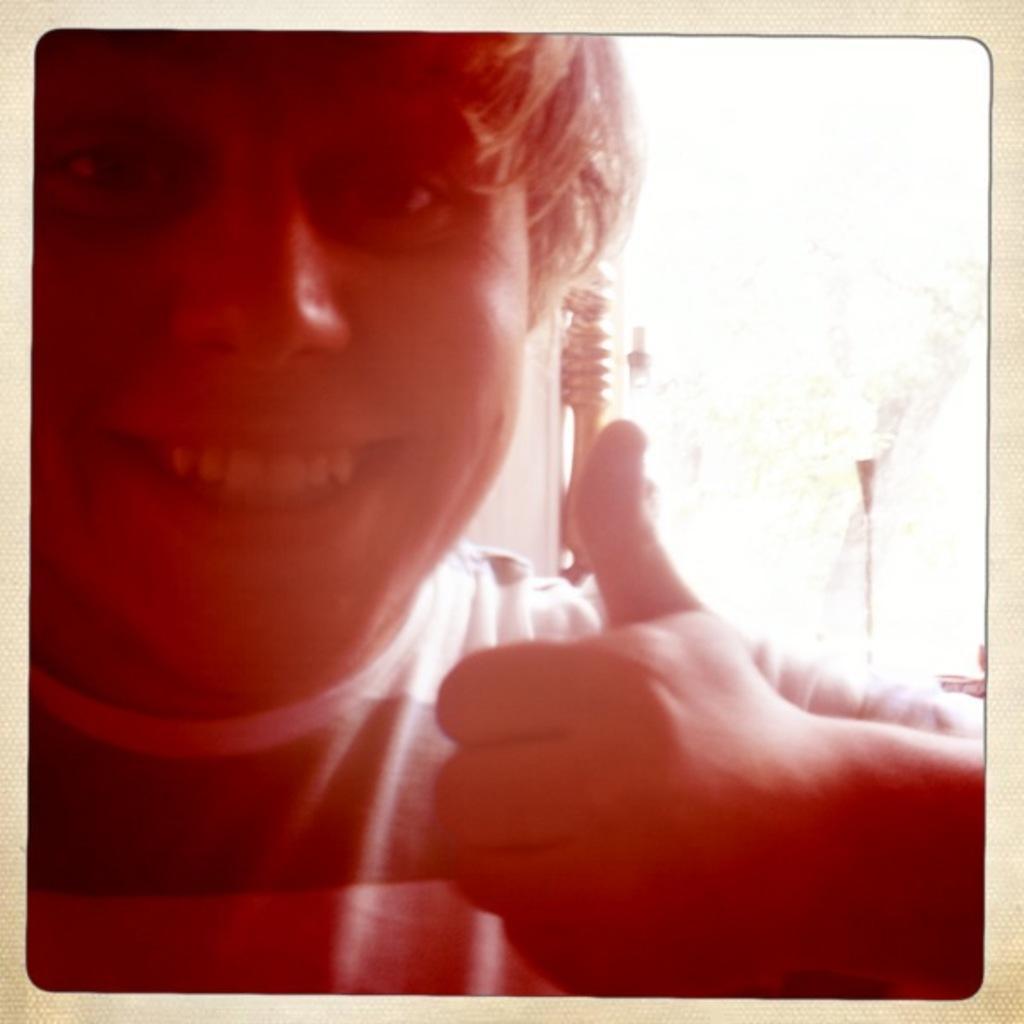How would you summarize this image in a sentence or two? In this image we can see a person wearing a t shirt is showing his thumb finger. In the background we can see group of poles. 